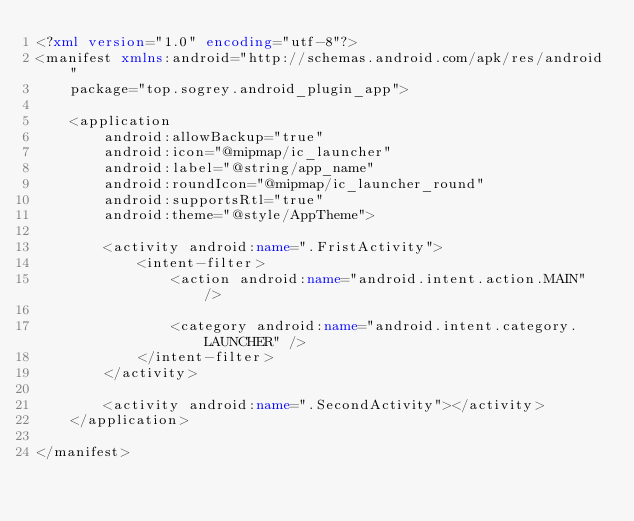<code> <loc_0><loc_0><loc_500><loc_500><_XML_><?xml version="1.0" encoding="utf-8"?>
<manifest xmlns:android="http://schemas.android.com/apk/res/android"
    package="top.sogrey.android_plugin_app">

    <application
        android:allowBackup="true"
        android:icon="@mipmap/ic_launcher"
        android:label="@string/app_name"
        android:roundIcon="@mipmap/ic_launcher_round"
        android:supportsRtl="true"
        android:theme="@style/AppTheme">

        <activity android:name=".FristActivity">
            <intent-filter>
                <action android:name="android.intent.action.MAIN" />

                <category android:name="android.intent.category.LAUNCHER" />
            </intent-filter>
        </activity>

        <activity android:name=".SecondActivity"></activity>
    </application>

</manifest></code> 